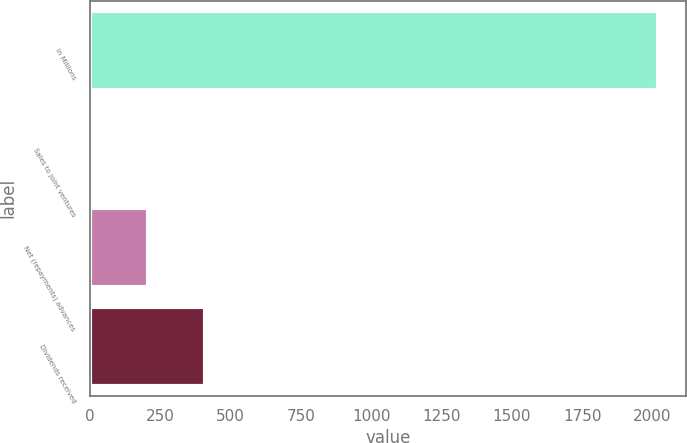Convert chart to OTSL. <chart><loc_0><loc_0><loc_500><loc_500><bar_chart><fcel>In Millions<fcel>Sales to joint ventures<fcel>Net (repayments) advances<fcel>Dividends received<nl><fcel>2018<fcel>7.4<fcel>208.46<fcel>409.52<nl></chart> 